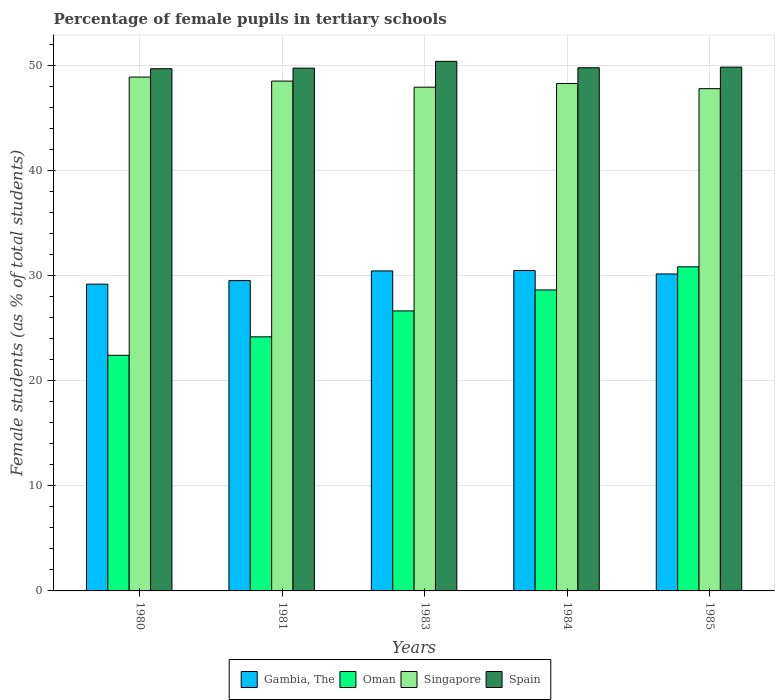How many groups of bars are there?
Your answer should be very brief. 5. In how many cases, is the number of bars for a given year not equal to the number of legend labels?
Your response must be concise. 0. What is the percentage of female pupils in tertiary schools in Singapore in 1983?
Give a very brief answer. 47.96. Across all years, what is the maximum percentage of female pupils in tertiary schools in Spain?
Your response must be concise. 50.42. Across all years, what is the minimum percentage of female pupils in tertiary schools in Singapore?
Offer a terse response. 47.82. In which year was the percentage of female pupils in tertiary schools in Oman minimum?
Ensure brevity in your answer.  1980. What is the total percentage of female pupils in tertiary schools in Gambia, The in the graph?
Keep it short and to the point. 149.9. What is the difference between the percentage of female pupils in tertiary schools in Spain in 1981 and that in 1985?
Your response must be concise. -0.1. What is the difference between the percentage of female pupils in tertiary schools in Gambia, The in 1983 and the percentage of female pupils in tertiary schools in Spain in 1985?
Your answer should be compact. -19.4. What is the average percentage of female pupils in tertiary schools in Spain per year?
Ensure brevity in your answer.  49.91. In the year 1980, what is the difference between the percentage of female pupils in tertiary schools in Spain and percentage of female pupils in tertiary schools in Oman?
Offer a very short reply. 27.28. What is the ratio of the percentage of female pupils in tertiary schools in Singapore in 1980 to that in 1985?
Keep it short and to the point. 1.02. What is the difference between the highest and the second highest percentage of female pupils in tertiary schools in Gambia, The?
Ensure brevity in your answer.  0.04. What is the difference between the highest and the lowest percentage of female pupils in tertiary schools in Oman?
Your answer should be compact. 8.42. In how many years, is the percentage of female pupils in tertiary schools in Singapore greater than the average percentage of female pupils in tertiary schools in Singapore taken over all years?
Provide a short and direct response. 3. Is it the case that in every year, the sum of the percentage of female pupils in tertiary schools in Gambia, The and percentage of female pupils in tertiary schools in Spain is greater than the sum of percentage of female pupils in tertiary schools in Singapore and percentage of female pupils in tertiary schools in Oman?
Ensure brevity in your answer.  Yes. What does the 2nd bar from the left in 1985 represents?
Ensure brevity in your answer.  Oman. What does the 4th bar from the right in 1983 represents?
Offer a terse response. Gambia, The. Is it the case that in every year, the sum of the percentage of female pupils in tertiary schools in Singapore and percentage of female pupils in tertiary schools in Gambia, The is greater than the percentage of female pupils in tertiary schools in Oman?
Give a very brief answer. Yes. What is the difference between two consecutive major ticks on the Y-axis?
Your answer should be compact. 10. Are the values on the major ticks of Y-axis written in scientific E-notation?
Ensure brevity in your answer.  No. Does the graph contain grids?
Make the answer very short. Yes. Where does the legend appear in the graph?
Ensure brevity in your answer.  Bottom center. How many legend labels are there?
Offer a terse response. 4. How are the legend labels stacked?
Make the answer very short. Horizontal. What is the title of the graph?
Give a very brief answer. Percentage of female pupils in tertiary schools. What is the label or title of the X-axis?
Keep it short and to the point. Years. What is the label or title of the Y-axis?
Give a very brief answer. Female students (as % of total students). What is the Female students (as % of total students) of Gambia, The in 1980?
Keep it short and to the point. 29.21. What is the Female students (as % of total students) of Oman in 1980?
Ensure brevity in your answer.  22.43. What is the Female students (as % of total students) of Singapore in 1980?
Your response must be concise. 48.92. What is the Female students (as % of total students) of Spain in 1980?
Your response must be concise. 49.71. What is the Female students (as % of total students) of Gambia, The in 1981?
Provide a short and direct response. 29.54. What is the Female students (as % of total students) in Oman in 1981?
Your answer should be very brief. 24.19. What is the Female students (as % of total students) of Singapore in 1981?
Give a very brief answer. 48.54. What is the Female students (as % of total students) in Spain in 1981?
Your answer should be compact. 49.77. What is the Female students (as % of total students) of Gambia, The in 1983?
Offer a very short reply. 30.47. What is the Female students (as % of total students) of Oman in 1983?
Offer a terse response. 26.66. What is the Female students (as % of total students) in Singapore in 1983?
Keep it short and to the point. 47.96. What is the Female students (as % of total students) of Spain in 1983?
Keep it short and to the point. 50.42. What is the Female students (as % of total students) of Gambia, The in 1984?
Provide a short and direct response. 30.51. What is the Female students (as % of total students) in Oman in 1984?
Your answer should be compact. 28.65. What is the Female students (as % of total students) in Singapore in 1984?
Your answer should be very brief. 48.31. What is the Female students (as % of total students) of Spain in 1984?
Provide a succinct answer. 49.81. What is the Female students (as % of total students) in Gambia, The in 1985?
Your answer should be compact. 30.18. What is the Female students (as % of total students) in Oman in 1985?
Offer a terse response. 30.86. What is the Female students (as % of total students) of Singapore in 1985?
Offer a very short reply. 47.82. What is the Female students (as % of total students) in Spain in 1985?
Give a very brief answer. 49.87. Across all years, what is the maximum Female students (as % of total students) of Gambia, The?
Keep it short and to the point. 30.51. Across all years, what is the maximum Female students (as % of total students) in Oman?
Ensure brevity in your answer.  30.86. Across all years, what is the maximum Female students (as % of total students) in Singapore?
Provide a succinct answer. 48.92. Across all years, what is the maximum Female students (as % of total students) in Spain?
Provide a succinct answer. 50.42. Across all years, what is the minimum Female students (as % of total students) in Gambia, The?
Offer a very short reply. 29.21. Across all years, what is the minimum Female students (as % of total students) in Oman?
Your answer should be very brief. 22.43. Across all years, what is the minimum Female students (as % of total students) in Singapore?
Give a very brief answer. 47.82. Across all years, what is the minimum Female students (as % of total students) in Spain?
Your answer should be compact. 49.71. What is the total Female students (as % of total students) in Gambia, The in the graph?
Your answer should be very brief. 149.9. What is the total Female students (as % of total students) in Oman in the graph?
Provide a short and direct response. 132.79. What is the total Female students (as % of total students) in Singapore in the graph?
Make the answer very short. 241.54. What is the total Female students (as % of total students) of Spain in the graph?
Make the answer very short. 249.57. What is the difference between the Female students (as % of total students) in Gambia, The in 1980 and that in 1981?
Provide a short and direct response. -0.34. What is the difference between the Female students (as % of total students) of Oman in 1980 and that in 1981?
Your answer should be compact. -1.76. What is the difference between the Female students (as % of total students) in Singapore in 1980 and that in 1981?
Keep it short and to the point. 0.38. What is the difference between the Female students (as % of total students) in Spain in 1980 and that in 1981?
Give a very brief answer. -0.06. What is the difference between the Female students (as % of total students) in Gambia, The in 1980 and that in 1983?
Your answer should be compact. -1.26. What is the difference between the Female students (as % of total students) in Oman in 1980 and that in 1983?
Offer a terse response. -4.22. What is the difference between the Female students (as % of total students) of Singapore in 1980 and that in 1983?
Offer a terse response. 0.96. What is the difference between the Female students (as % of total students) in Spain in 1980 and that in 1983?
Your response must be concise. -0.7. What is the difference between the Female students (as % of total students) in Gambia, The in 1980 and that in 1984?
Ensure brevity in your answer.  -1.3. What is the difference between the Female students (as % of total students) in Oman in 1980 and that in 1984?
Your response must be concise. -6.22. What is the difference between the Female students (as % of total students) in Singapore in 1980 and that in 1984?
Your response must be concise. 0.61. What is the difference between the Female students (as % of total students) of Spain in 1980 and that in 1984?
Offer a very short reply. -0.1. What is the difference between the Female students (as % of total students) of Gambia, The in 1980 and that in 1985?
Make the answer very short. -0.97. What is the difference between the Female students (as % of total students) of Oman in 1980 and that in 1985?
Your answer should be compact. -8.42. What is the difference between the Female students (as % of total students) of Singapore in 1980 and that in 1985?
Ensure brevity in your answer.  1.11. What is the difference between the Female students (as % of total students) of Spain in 1980 and that in 1985?
Provide a short and direct response. -0.15. What is the difference between the Female students (as % of total students) in Gambia, The in 1981 and that in 1983?
Offer a terse response. -0.92. What is the difference between the Female students (as % of total students) of Oman in 1981 and that in 1983?
Your answer should be compact. -2.47. What is the difference between the Female students (as % of total students) in Singapore in 1981 and that in 1983?
Ensure brevity in your answer.  0.58. What is the difference between the Female students (as % of total students) of Spain in 1981 and that in 1983?
Offer a very short reply. -0.65. What is the difference between the Female students (as % of total students) of Gambia, The in 1981 and that in 1984?
Offer a very short reply. -0.96. What is the difference between the Female students (as % of total students) in Oman in 1981 and that in 1984?
Provide a short and direct response. -4.46. What is the difference between the Female students (as % of total students) of Singapore in 1981 and that in 1984?
Make the answer very short. 0.23. What is the difference between the Female students (as % of total students) in Spain in 1981 and that in 1984?
Make the answer very short. -0.04. What is the difference between the Female students (as % of total students) of Gambia, The in 1981 and that in 1985?
Provide a succinct answer. -0.63. What is the difference between the Female students (as % of total students) in Oman in 1981 and that in 1985?
Provide a short and direct response. -6.67. What is the difference between the Female students (as % of total students) of Singapore in 1981 and that in 1985?
Your response must be concise. 0.72. What is the difference between the Female students (as % of total students) in Spain in 1981 and that in 1985?
Your response must be concise. -0.1. What is the difference between the Female students (as % of total students) of Gambia, The in 1983 and that in 1984?
Offer a terse response. -0.04. What is the difference between the Female students (as % of total students) of Oman in 1983 and that in 1984?
Keep it short and to the point. -2. What is the difference between the Female students (as % of total students) of Singapore in 1983 and that in 1984?
Ensure brevity in your answer.  -0.35. What is the difference between the Female students (as % of total students) of Spain in 1983 and that in 1984?
Keep it short and to the point. 0.61. What is the difference between the Female students (as % of total students) of Gambia, The in 1983 and that in 1985?
Your answer should be compact. 0.29. What is the difference between the Female students (as % of total students) of Oman in 1983 and that in 1985?
Your response must be concise. -4.2. What is the difference between the Female students (as % of total students) of Singapore in 1983 and that in 1985?
Your answer should be very brief. 0.14. What is the difference between the Female students (as % of total students) in Spain in 1983 and that in 1985?
Give a very brief answer. 0.55. What is the difference between the Female students (as % of total students) of Gambia, The in 1984 and that in 1985?
Keep it short and to the point. 0.33. What is the difference between the Female students (as % of total students) in Oman in 1984 and that in 1985?
Your response must be concise. -2.2. What is the difference between the Female students (as % of total students) of Singapore in 1984 and that in 1985?
Provide a short and direct response. 0.49. What is the difference between the Female students (as % of total students) in Spain in 1984 and that in 1985?
Provide a short and direct response. -0.06. What is the difference between the Female students (as % of total students) in Gambia, The in 1980 and the Female students (as % of total students) in Oman in 1981?
Offer a terse response. 5.02. What is the difference between the Female students (as % of total students) in Gambia, The in 1980 and the Female students (as % of total students) in Singapore in 1981?
Provide a short and direct response. -19.33. What is the difference between the Female students (as % of total students) of Gambia, The in 1980 and the Female students (as % of total students) of Spain in 1981?
Give a very brief answer. -20.56. What is the difference between the Female students (as % of total students) in Oman in 1980 and the Female students (as % of total students) in Singapore in 1981?
Provide a succinct answer. -26.1. What is the difference between the Female students (as % of total students) of Oman in 1980 and the Female students (as % of total students) of Spain in 1981?
Your answer should be very brief. -27.34. What is the difference between the Female students (as % of total students) in Singapore in 1980 and the Female students (as % of total students) in Spain in 1981?
Keep it short and to the point. -0.85. What is the difference between the Female students (as % of total students) in Gambia, The in 1980 and the Female students (as % of total students) in Oman in 1983?
Provide a short and direct response. 2.55. What is the difference between the Female students (as % of total students) in Gambia, The in 1980 and the Female students (as % of total students) in Singapore in 1983?
Ensure brevity in your answer.  -18.75. What is the difference between the Female students (as % of total students) of Gambia, The in 1980 and the Female students (as % of total students) of Spain in 1983?
Provide a succinct answer. -21.21. What is the difference between the Female students (as % of total students) in Oman in 1980 and the Female students (as % of total students) in Singapore in 1983?
Provide a short and direct response. -25.52. What is the difference between the Female students (as % of total students) in Oman in 1980 and the Female students (as % of total students) in Spain in 1983?
Ensure brevity in your answer.  -27.98. What is the difference between the Female students (as % of total students) of Singapore in 1980 and the Female students (as % of total students) of Spain in 1983?
Offer a very short reply. -1.49. What is the difference between the Female students (as % of total students) in Gambia, The in 1980 and the Female students (as % of total students) in Oman in 1984?
Your answer should be very brief. 0.55. What is the difference between the Female students (as % of total students) of Gambia, The in 1980 and the Female students (as % of total students) of Singapore in 1984?
Offer a very short reply. -19.1. What is the difference between the Female students (as % of total students) of Gambia, The in 1980 and the Female students (as % of total students) of Spain in 1984?
Your response must be concise. -20.6. What is the difference between the Female students (as % of total students) of Oman in 1980 and the Female students (as % of total students) of Singapore in 1984?
Ensure brevity in your answer.  -25.88. What is the difference between the Female students (as % of total students) in Oman in 1980 and the Female students (as % of total students) in Spain in 1984?
Your response must be concise. -27.37. What is the difference between the Female students (as % of total students) in Singapore in 1980 and the Female students (as % of total students) in Spain in 1984?
Provide a short and direct response. -0.89. What is the difference between the Female students (as % of total students) in Gambia, The in 1980 and the Female students (as % of total students) in Oman in 1985?
Your answer should be compact. -1.65. What is the difference between the Female students (as % of total students) in Gambia, The in 1980 and the Female students (as % of total students) in Singapore in 1985?
Provide a succinct answer. -18.61. What is the difference between the Female students (as % of total students) in Gambia, The in 1980 and the Female students (as % of total students) in Spain in 1985?
Offer a terse response. -20.66. What is the difference between the Female students (as % of total students) of Oman in 1980 and the Female students (as % of total students) of Singapore in 1985?
Ensure brevity in your answer.  -25.38. What is the difference between the Female students (as % of total students) of Oman in 1980 and the Female students (as % of total students) of Spain in 1985?
Your response must be concise. -27.43. What is the difference between the Female students (as % of total students) in Singapore in 1980 and the Female students (as % of total students) in Spain in 1985?
Give a very brief answer. -0.94. What is the difference between the Female students (as % of total students) in Gambia, The in 1981 and the Female students (as % of total students) in Oman in 1983?
Provide a succinct answer. 2.89. What is the difference between the Female students (as % of total students) in Gambia, The in 1981 and the Female students (as % of total students) in Singapore in 1983?
Your response must be concise. -18.41. What is the difference between the Female students (as % of total students) of Gambia, The in 1981 and the Female students (as % of total students) of Spain in 1983?
Your answer should be compact. -20.87. What is the difference between the Female students (as % of total students) in Oman in 1981 and the Female students (as % of total students) in Singapore in 1983?
Provide a succinct answer. -23.77. What is the difference between the Female students (as % of total students) in Oman in 1981 and the Female students (as % of total students) in Spain in 1983?
Offer a terse response. -26.23. What is the difference between the Female students (as % of total students) of Singapore in 1981 and the Female students (as % of total students) of Spain in 1983?
Your answer should be compact. -1.88. What is the difference between the Female students (as % of total students) in Gambia, The in 1981 and the Female students (as % of total students) in Oman in 1984?
Provide a succinct answer. 0.89. What is the difference between the Female students (as % of total students) in Gambia, The in 1981 and the Female students (as % of total students) in Singapore in 1984?
Your response must be concise. -18.77. What is the difference between the Female students (as % of total students) in Gambia, The in 1981 and the Female students (as % of total students) in Spain in 1984?
Provide a short and direct response. -20.26. What is the difference between the Female students (as % of total students) of Oman in 1981 and the Female students (as % of total students) of Singapore in 1984?
Ensure brevity in your answer.  -24.12. What is the difference between the Female students (as % of total students) in Oman in 1981 and the Female students (as % of total students) in Spain in 1984?
Offer a terse response. -25.62. What is the difference between the Female students (as % of total students) in Singapore in 1981 and the Female students (as % of total students) in Spain in 1984?
Your answer should be very brief. -1.27. What is the difference between the Female students (as % of total students) of Gambia, The in 1981 and the Female students (as % of total students) of Oman in 1985?
Offer a very short reply. -1.31. What is the difference between the Female students (as % of total students) in Gambia, The in 1981 and the Female students (as % of total students) in Singapore in 1985?
Provide a short and direct response. -18.27. What is the difference between the Female students (as % of total students) in Gambia, The in 1981 and the Female students (as % of total students) in Spain in 1985?
Provide a short and direct response. -20.32. What is the difference between the Female students (as % of total students) of Oman in 1981 and the Female students (as % of total students) of Singapore in 1985?
Your answer should be very brief. -23.63. What is the difference between the Female students (as % of total students) of Oman in 1981 and the Female students (as % of total students) of Spain in 1985?
Provide a short and direct response. -25.68. What is the difference between the Female students (as % of total students) of Singapore in 1981 and the Female students (as % of total students) of Spain in 1985?
Provide a short and direct response. -1.33. What is the difference between the Female students (as % of total students) of Gambia, The in 1983 and the Female students (as % of total students) of Oman in 1984?
Ensure brevity in your answer.  1.81. What is the difference between the Female students (as % of total students) in Gambia, The in 1983 and the Female students (as % of total students) in Singapore in 1984?
Ensure brevity in your answer.  -17.84. What is the difference between the Female students (as % of total students) in Gambia, The in 1983 and the Female students (as % of total students) in Spain in 1984?
Offer a terse response. -19.34. What is the difference between the Female students (as % of total students) in Oman in 1983 and the Female students (as % of total students) in Singapore in 1984?
Your response must be concise. -21.65. What is the difference between the Female students (as % of total students) in Oman in 1983 and the Female students (as % of total students) in Spain in 1984?
Offer a terse response. -23.15. What is the difference between the Female students (as % of total students) of Singapore in 1983 and the Female students (as % of total students) of Spain in 1984?
Your answer should be very brief. -1.85. What is the difference between the Female students (as % of total students) of Gambia, The in 1983 and the Female students (as % of total students) of Oman in 1985?
Keep it short and to the point. -0.39. What is the difference between the Female students (as % of total students) of Gambia, The in 1983 and the Female students (as % of total students) of Singapore in 1985?
Provide a short and direct response. -17.35. What is the difference between the Female students (as % of total students) of Gambia, The in 1983 and the Female students (as % of total students) of Spain in 1985?
Your answer should be compact. -19.4. What is the difference between the Female students (as % of total students) of Oman in 1983 and the Female students (as % of total students) of Singapore in 1985?
Offer a terse response. -21.16. What is the difference between the Female students (as % of total students) in Oman in 1983 and the Female students (as % of total students) in Spain in 1985?
Give a very brief answer. -23.21. What is the difference between the Female students (as % of total students) in Singapore in 1983 and the Female students (as % of total students) in Spain in 1985?
Make the answer very short. -1.91. What is the difference between the Female students (as % of total students) in Gambia, The in 1984 and the Female students (as % of total students) in Oman in 1985?
Give a very brief answer. -0.35. What is the difference between the Female students (as % of total students) of Gambia, The in 1984 and the Female students (as % of total students) of Singapore in 1985?
Provide a succinct answer. -17.31. What is the difference between the Female students (as % of total students) of Gambia, The in 1984 and the Female students (as % of total students) of Spain in 1985?
Provide a succinct answer. -19.36. What is the difference between the Female students (as % of total students) in Oman in 1984 and the Female students (as % of total students) in Singapore in 1985?
Provide a succinct answer. -19.16. What is the difference between the Female students (as % of total students) in Oman in 1984 and the Female students (as % of total students) in Spain in 1985?
Ensure brevity in your answer.  -21.21. What is the difference between the Female students (as % of total students) of Singapore in 1984 and the Female students (as % of total students) of Spain in 1985?
Make the answer very short. -1.56. What is the average Female students (as % of total students) of Gambia, The per year?
Your response must be concise. 29.98. What is the average Female students (as % of total students) in Oman per year?
Keep it short and to the point. 26.56. What is the average Female students (as % of total students) of Singapore per year?
Your answer should be compact. 48.31. What is the average Female students (as % of total students) in Spain per year?
Your response must be concise. 49.91. In the year 1980, what is the difference between the Female students (as % of total students) in Gambia, The and Female students (as % of total students) in Oman?
Your answer should be very brief. 6.77. In the year 1980, what is the difference between the Female students (as % of total students) of Gambia, The and Female students (as % of total students) of Singapore?
Offer a very short reply. -19.72. In the year 1980, what is the difference between the Female students (as % of total students) of Gambia, The and Female students (as % of total students) of Spain?
Keep it short and to the point. -20.51. In the year 1980, what is the difference between the Female students (as % of total students) of Oman and Female students (as % of total students) of Singapore?
Make the answer very short. -26.49. In the year 1980, what is the difference between the Female students (as % of total students) in Oman and Female students (as % of total students) in Spain?
Provide a short and direct response. -27.28. In the year 1980, what is the difference between the Female students (as % of total students) in Singapore and Female students (as % of total students) in Spain?
Make the answer very short. -0.79. In the year 1981, what is the difference between the Female students (as % of total students) in Gambia, The and Female students (as % of total students) in Oman?
Your answer should be compact. 5.35. In the year 1981, what is the difference between the Female students (as % of total students) of Gambia, The and Female students (as % of total students) of Singapore?
Ensure brevity in your answer.  -18.99. In the year 1981, what is the difference between the Female students (as % of total students) of Gambia, The and Female students (as % of total students) of Spain?
Keep it short and to the point. -20.23. In the year 1981, what is the difference between the Female students (as % of total students) in Oman and Female students (as % of total students) in Singapore?
Ensure brevity in your answer.  -24.35. In the year 1981, what is the difference between the Female students (as % of total students) in Oman and Female students (as % of total students) in Spain?
Your response must be concise. -25.58. In the year 1981, what is the difference between the Female students (as % of total students) in Singapore and Female students (as % of total students) in Spain?
Give a very brief answer. -1.23. In the year 1983, what is the difference between the Female students (as % of total students) in Gambia, The and Female students (as % of total students) in Oman?
Your answer should be compact. 3.81. In the year 1983, what is the difference between the Female students (as % of total students) in Gambia, The and Female students (as % of total students) in Singapore?
Your answer should be very brief. -17.49. In the year 1983, what is the difference between the Female students (as % of total students) of Gambia, The and Female students (as % of total students) of Spain?
Ensure brevity in your answer.  -19.95. In the year 1983, what is the difference between the Female students (as % of total students) of Oman and Female students (as % of total students) of Singapore?
Your answer should be very brief. -21.3. In the year 1983, what is the difference between the Female students (as % of total students) in Oman and Female students (as % of total students) in Spain?
Make the answer very short. -23.76. In the year 1983, what is the difference between the Female students (as % of total students) of Singapore and Female students (as % of total students) of Spain?
Keep it short and to the point. -2.46. In the year 1984, what is the difference between the Female students (as % of total students) in Gambia, The and Female students (as % of total students) in Oman?
Keep it short and to the point. 1.85. In the year 1984, what is the difference between the Female students (as % of total students) in Gambia, The and Female students (as % of total students) in Singapore?
Your answer should be compact. -17.8. In the year 1984, what is the difference between the Female students (as % of total students) of Gambia, The and Female students (as % of total students) of Spain?
Provide a short and direct response. -19.3. In the year 1984, what is the difference between the Female students (as % of total students) of Oman and Female students (as % of total students) of Singapore?
Make the answer very short. -19.66. In the year 1984, what is the difference between the Female students (as % of total students) in Oman and Female students (as % of total students) in Spain?
Offer a very short reply. -21.15. In the year 1984, what is the difference between the Female students (as % of total students) in Singapore and Female students (as % of total students) in Spain?
Ensure brevity in your answer.  -1.5. In the year 1985, what is the difference between the Female students (as % of total students) of Gambia, The and Female students (as % of total students) of Oman?
Your answer should be very brief. -0.68. In the year 1985, what is the difference between the Female students (as % of total students) in Gambia, The and Female students (as % of total students) in Singapore?
Your response must be concise. -17.64. In the year 1985, what is the difference between the Female students (as % of total students) in Gambia, The and Female students (as % of total students) in Spain?
Provide a succinct answer. -19.69. In the year 1985, what is the difference between the Female students (as % of total students) of Oman and Female students (as % of total students) of Singapore?
Make the answer very short. -16.96. In the year 1985, what is the difference between the Female students (as % of total students) of Oman and Female students (as % of total students) of Spain?
Keep it short and to the point. -19.01. In the year 1985, what is the difference between the Female students (as % of total students) in Singapore and Female students (as % of total students) in Spain?
Provide a short and direct response. -2.05. What is the ratio of the Female students (as % of total students) of Oman in 1980 to that in 1981?
Ensure brevity in your answer.  0.93. What is the ratio of the Female students (as % of total students) of Singapore in 1980 to that in 1981?
Provide a succinct answer. 1.01. What is the ratio of the Female students (as % of total students) of Spain in 1980 to that in 1981?
Provide a short and direct response. 1. What is the ratio of the Female students (as % of total students) in Gambia, The in 1980 to that in 1983?
Provide a short and direct response. 0.96. What is the ratio of the Female students (as % of total students) in Oman in 1980 to that in 1983?
Ensure brevity in your answer.  0.84. What is the ratio of the Female students (as % of total students) of Singapore in 1980 to that in 1983?
Make the answer very short. 1.02. What is the ratio of the Female students (as % of total students) in Spain in 1980 to that in 1983?
Your response must be concise. 0.99. What is the ratio of the Female students (as % of total students) in Gambia, The in 1980 to that in 1984?
Provide a succinct answer. 0.96. What is the ratio of the Female students (as % of total students) in Oman in 1980 to that in 1984?
Your answer should be compact. 0.78. What is the ratio of the Female students (as % of total students) in Singapore in 1980 to that in 1984?
Your answer should be very brief. 1.01. What is the ratio of the Female students (as % of total students) in Spain in 1980 to that in 1984?
Offer a terse response. 1. What is the ratio of the Female students (as % of total students) in Gambia, The in 1980 to that in 1985?
Make the answer very short. 0.97. What is the ratio of the Female students (as % of total students) of Oman in 1980 to that in 1985?
Your response must be concise. 0.73. What is the ratio of the Female students (as % of total students) of Singapore in 1980 to that in 1985?
Your answer should be compact. 1.02. What is the ratio of the Female students (as % of total students) of Spain in 1980 to that in 1985?
Your answer should be compact. 1. What is the ratio of the Female students (as % of total students) of Gambia, The in 1981 to that in 1983?
Your answer should be compact. 0.97. What is the ratio of the Female students (as % of total students) in Oman in 1981 to that in 1983?
Give a very brief answer. 0.91. What is the ratio of the Female students (as % of total students) in Singapore in 1981 to that in 1983?
Your response must be concise. 1.01. What is the ratio of the Female students (as % of total students) in Spain in 1981 to that in 1983?
Ensure brevity in your answer.  0.99. What is the ratio of the Female students (as % of total students) in Gambia, The in 1981 to that in 1984?
Make the answer very short. 0.97. What is the ratio of the Female students (as % of total students) in Oman in 1981 to that in 1984?
Offer a very short reply. 0.84. What is the ratio of the Female students (as % of total students) of Singapore in 1981 to that in 1984?
Provide a short and direct response. 1. What is the ratio of the Female students (as % of total students) of Spain in 1981 to that in 1984?
Your response must be concise. 1. What is the ratio of the Female students (as % of total students) of Gambia, The in 1981 to that in 1985?
Provide a succinct answer. 0.98. What is the ratio of the Female students (as % of total students) in Oman in 1981 to that in 1985?
Ensure brevity in your answer.  0.78. What is the ratio of the Female students (as % of total students) in Singapore in 1981 to that in 1985?
Your answer should be very brief. 1.02. What is the ratio of the Female students (as % of total students) of Gambia, The in 1983 to that in 1984?
Your response must be concise. 1. What is the ratio of the Female students (as % of total students) in Oman in 1983 to that in 1984?
Offer a very short reply. 0.93. What is the ratio of the Female students (as % of total students) in Spain in 1983 to that in 1984?
Your response must be concise. 1.01. What is the ratio of the Female students (as % of total students) in Gambia, The in 1983 to that in 1985?
Give a very brief answer. 1.01. What is the ratio of the Female students (as % of total students) of Oman in 1983 to that in 1985?
Your answer should be compact. 0.86. What is the ratio of the Female students (as % of total students) of Spain in 1983 to that in 1985?
Your answer should be compact. 1.01. What is the ratio of the Female students (as % of total students) of Gambia, The in 1984 to that in 1985?
Ensure brevity in your answer.  1.01. What is the ratio of the Female students (as % of total students) in Singapore in 1984 to that in 1985?
Ensure brevity in your answer.  1.01. What is the ratio of the Female students (as % of total students) in Spain in 1984 to that in 1985?
Make the answer very short. 1. What is the difference between the highest and the second highest Female students (as % of total students) of Gambia, The?
Your response must be concise. 0.04. What is the difference between the highest and the second highest Female students (as % of total students) of Oman?
Your answer should be very brief. 2.2. What is the difference between the highest and the second highest Female students (as % of total students) of Singapore?
Give a very brief answer. 0.38. What is the difference between the highest and the second highest Female students (as % of total students) in Spain?
Offer a terse response. 0.55. What is the difference between the highest and the lowest Female students (as % of total students) in Gambia, The?
Your response must be concise. 1.3. What is the difference between the highest and the lowest Female students (as % of total students) of Oman?
Your answer should be compact. 8.42. What is the difference between the highest and the lowest Female students (as % of total students) in Singapore?
Your response must be concise. 1.11. What is the difference between the highest and the lowest Female students (as % of total students) in Spain?
Keep it short and to the point. 0.7. 